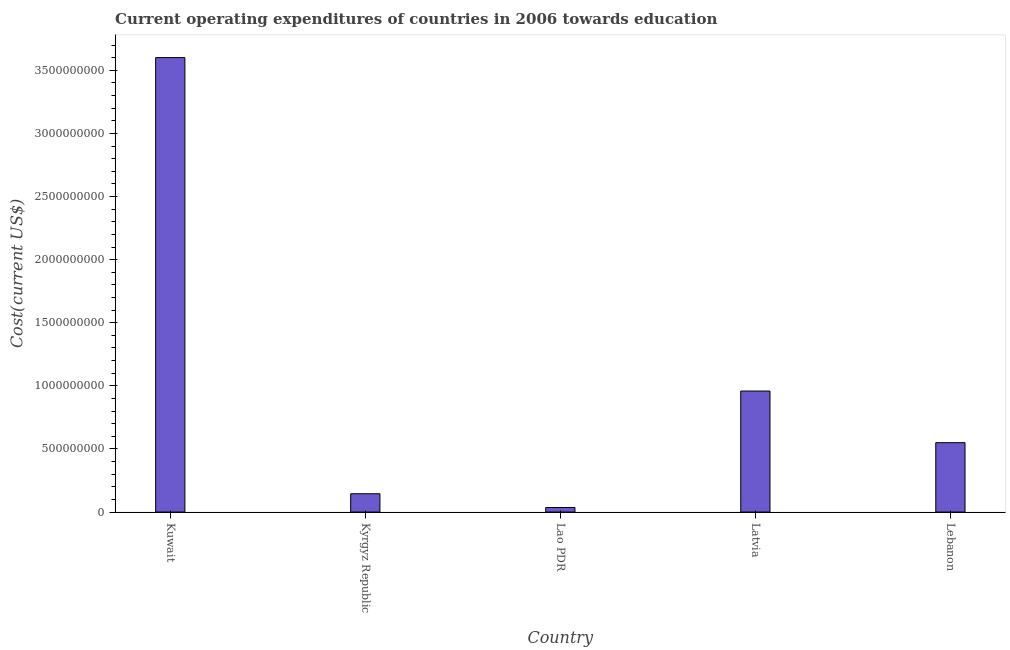What is the title of the graph?
Offer a terse response. Current operating expenditures of countries in 2006 towards education. What is the label or title of the Y-axis?
Your answer should be very brief. Cost(current US$). What is the education expenditure in Lao PDR?
Offer a terse response. 3.59e+07. Across all countries, what is the maximum education expenditure?
Your answer should be very brief. 3.60e+09. Across all countries, what is the minimum education expenditure?
Provide a succinct answer. 3.59e+07. In which country was the education expenditure maximum?
Your response must be concise. Kuwait. In which country was the education expenditure minimum?
Make the answer very short. Lao PDR. What is the sum of the education expenditure?
Keep it short and to the point. 5.29e+09. What is the difference between the education expenditure in Kyrgyz Republic and Lao PDR?
Make the answer very short. 1.09e+08. What is the average education expenditure per country?
Make the answer very short. 1.06e+09. What is the median education expenditure?
Provide a succinct answer. 5.49e+08. What is the ratio of the education expenditure in Kuwait to that in Lao PDR?
Provide a short and direct response. 100.34. Is the education expenditure in Kuwait less than that in Kyrgyz Republic?
Your answer should be compact. No. What is the difference between the highest and the second highest education expenditure?
Make the answer very short. 2.64e+09. What is the difference between the highest and the lowest education expenditure?
Your answer should be very brief. 3.56e+09. How many bars are there?
Offer a terse response. 5. How many countries are there in the graph?
Provide a succinct answer. 5. What is the difference between two consecutive major ticks on the Y-axis?
Your response must be concise. 5.00e+08. What is the Cost(current US$) of Kuwait?
Provide a succinct answer. 3.60e+09. What is the Cost(current US$) in Kyrgyz Republic?
Provide a short and direct response. 1.45e+08. What is the Cost(current US$) of Lao PDR?
Your answer should be compact. 3.59e+07. What is the Cost(current US$) of Latvia?
Provide a succinct answer. 9.59e+08. What is the Cost(current US$) of Lebanon?
Your response must be concise. 5.49e+08. What is the difference between the Cost(current US$) in Kuwait and Kyrgyz Republic?
Give a very brief answer. 3.46e+09. What is the difference between the Cost(current US$) in Kuwait and Lao PDR?
Offer a very short reply. 3.56e+09. What is the difference between the Cost(current US$) in Kuwait and Latvia?
Offer a terse response. 2.64e+09. What is the difference between the Cost(current US$) in Kuwait and Lebanon?
Keep it short and to the point. 3.05e+09. What is the difference between the Cost(current US$) in Kyrgyz Republic and Lao PDR?
Your answer should be compact. 1.09e+08. What is the difference between the Cost(current US$) in Kyrgyz Republic and Latvia?
Keep it short and to the point. -8.14e+08. What is the difference between the Cost(current US$) in Kyrgyz Republic and Lebanon?
Make the answer very short. -4.05e+08. What is the difference between the Cost(current US$) in Lao PDR and Latvia?
Keep it short and to the point. -9.23e+08. What is the difference between the Cost(current US$) in Lao PDR and Lebanon?
Make the answer very short. -5.14e+08. What is the difference between the Cost(current US$) in Latvia and Lebanon?
Give a very brief answer. 4.09e+08. What is the ratio of the Cost(current US$) in Kuwait to that in Kyrgyz Republic?
Your answer should be compact. 24.86. What is the ratio of the Cost(current US$) in Kuwait to that in Lao PDR?
Give a very brief answer. 100.34. What is the ratio of the Cost(current US$) in Kuwait to that in Latvia?
Provide a short and direct response. 3.76. What is the ratio of the Cost(current US$) in Kuwait to that in Lebanon?
Your response must be concise. 6.55. What is the ratio of the Cost(current US$) in Kyrgyz Republic to that in Lao PDR?
Your response must be concise. 4.04. What is the ratio of the Cost(current US$) in Kyrgyz Republic to that in Latvia?
Give a very brief answer. 0.15. What is the ratio of the Cost(current US$) in Kyrgyz Republic to that in Lebanon?
Offer a very short reply. 0.26. What is the ratio of the Cost(current US$) in Lao PDR to that in Latvia?
Offer a very short reply. 0.04. What is the ratio of the Cost(current US$) in Lao PDR to that in Lebanon?
Give a very brief answer. 0.07. What is the ratio of the Cost(current US$) in Latvia to that in Lebanon?
Your answer should be very brief. 1.75. 